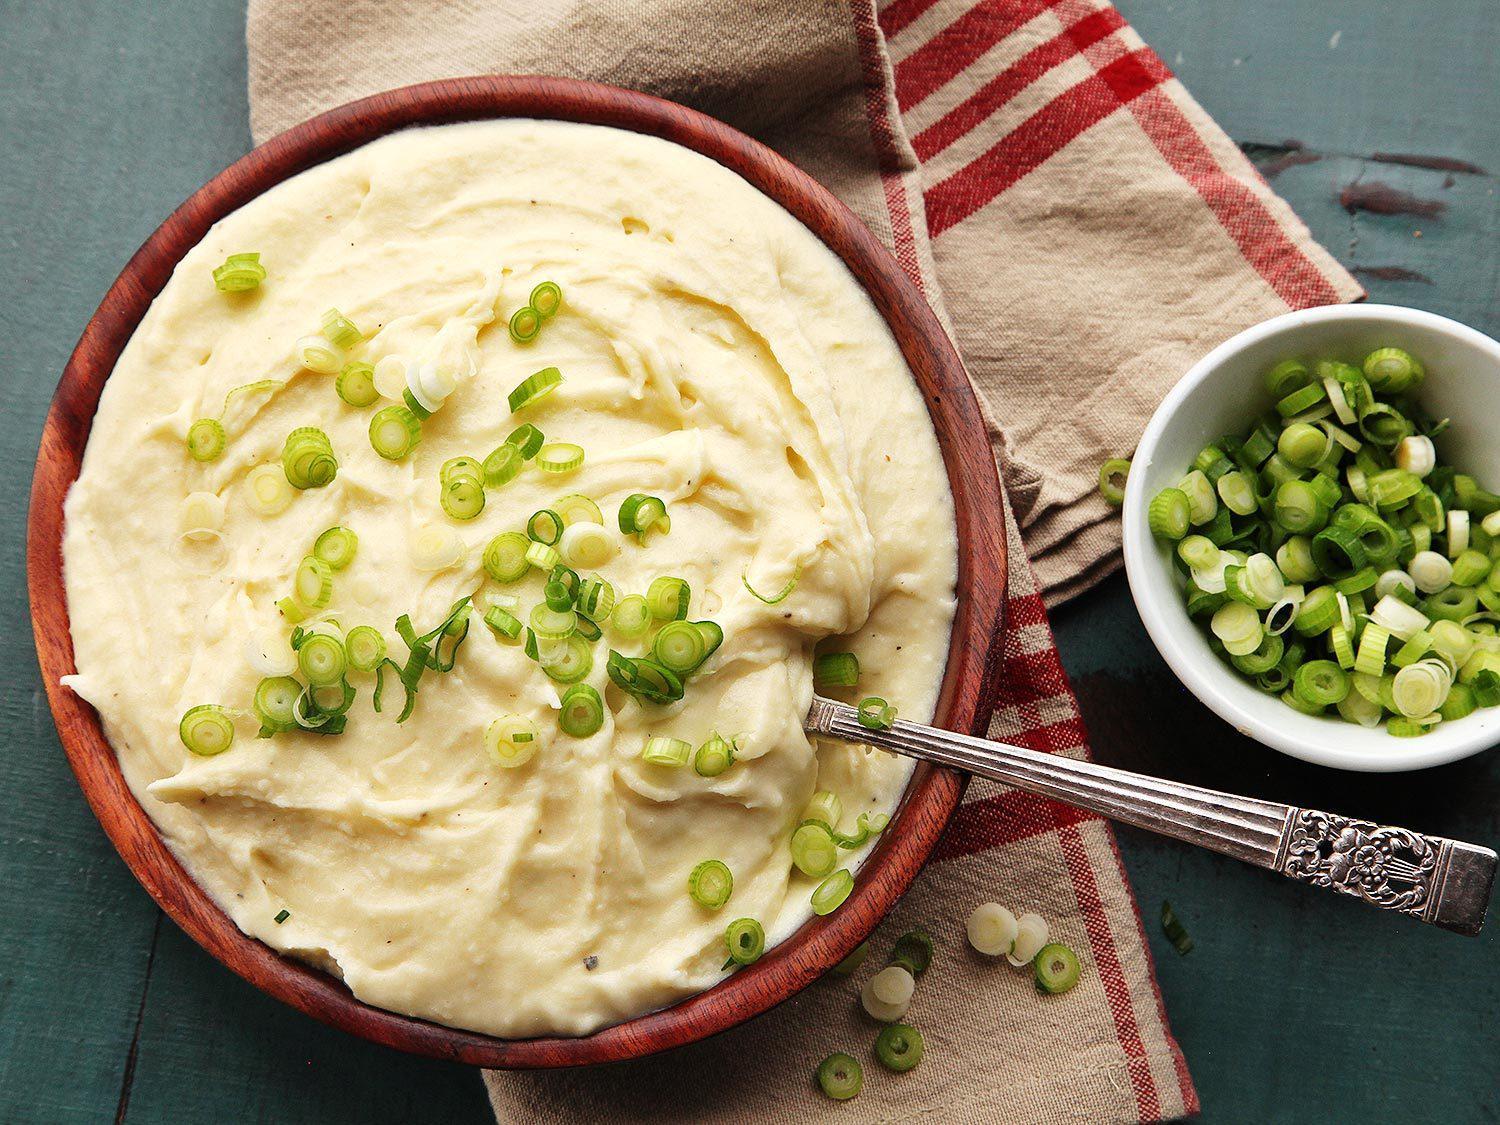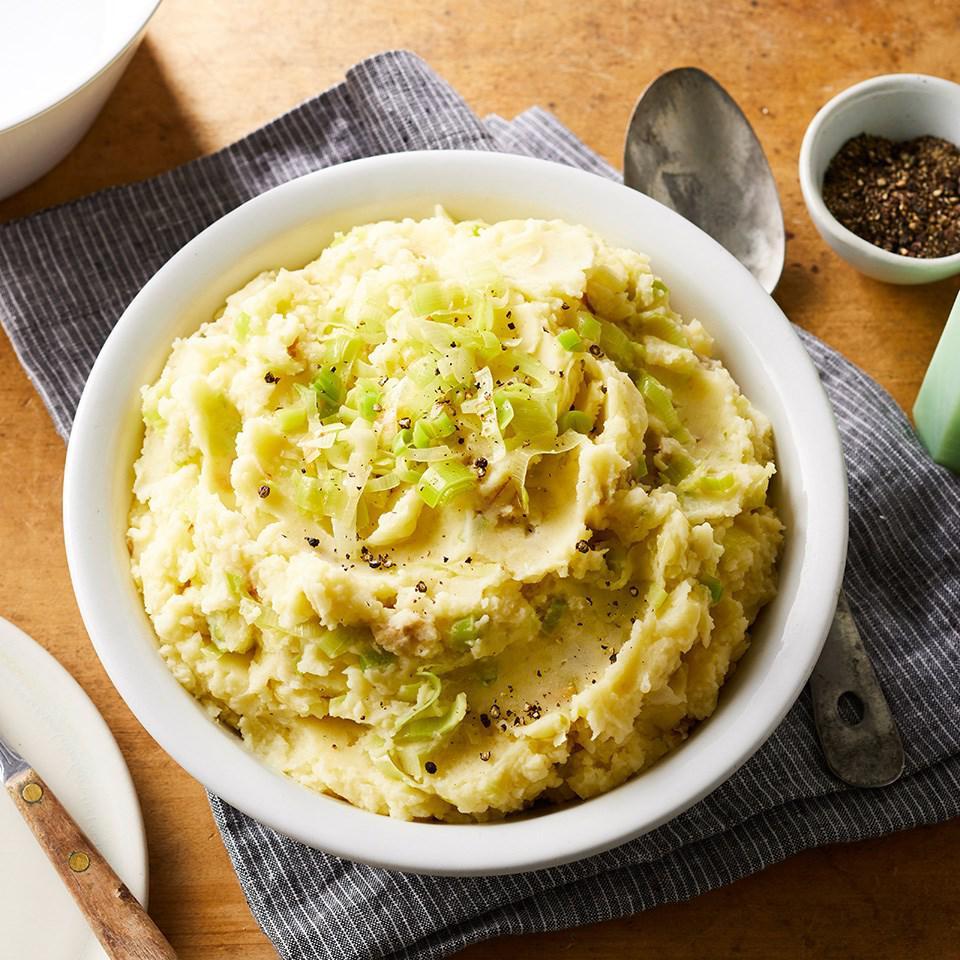The first image is the image on the left, the second image is the image on the right. Examine the images to the left and right. Is the description "The left and right image contains the same number of mash potatoes and chive bowls." accurate? Answer yes or no. Yes. The first image is the image on the left, the second image is the image on the right. Analyze the images presented: Is the assertion "The left image shows mashed potatoes with no green garnish while the other serving is topped with greens." valid? Answer yes or no. No. 